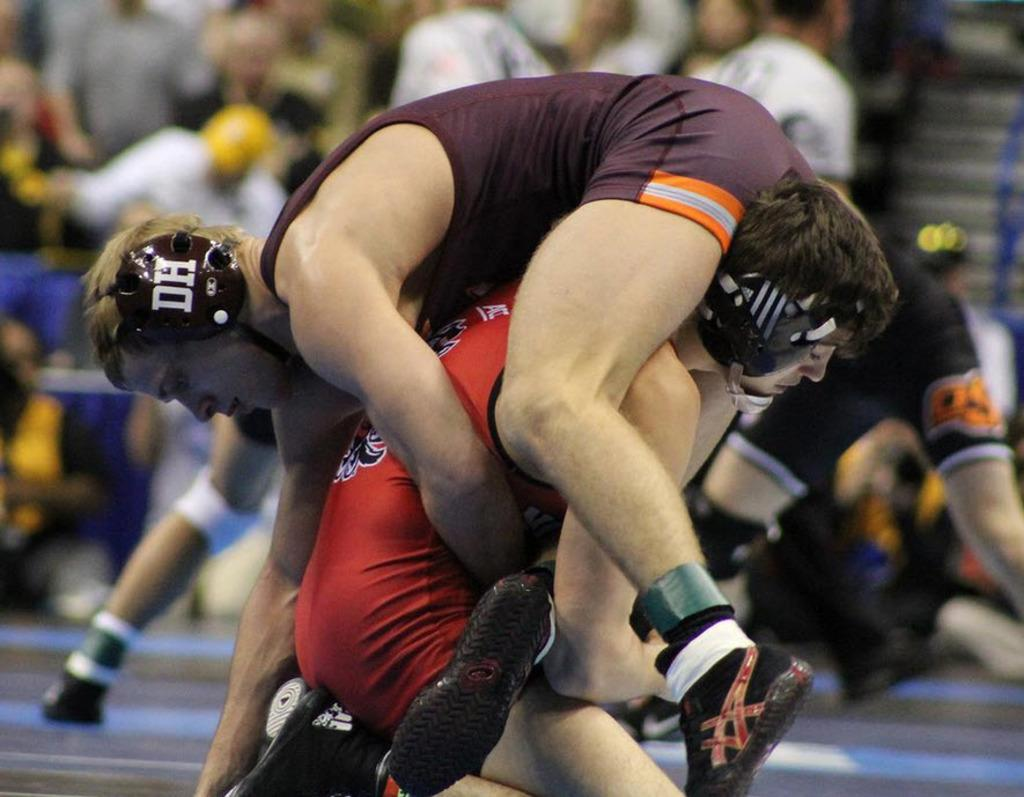<image>
Share a concise interpretation of the image provided. Two wrestlers wrestling with one wearing a helmet which says DH on it. 